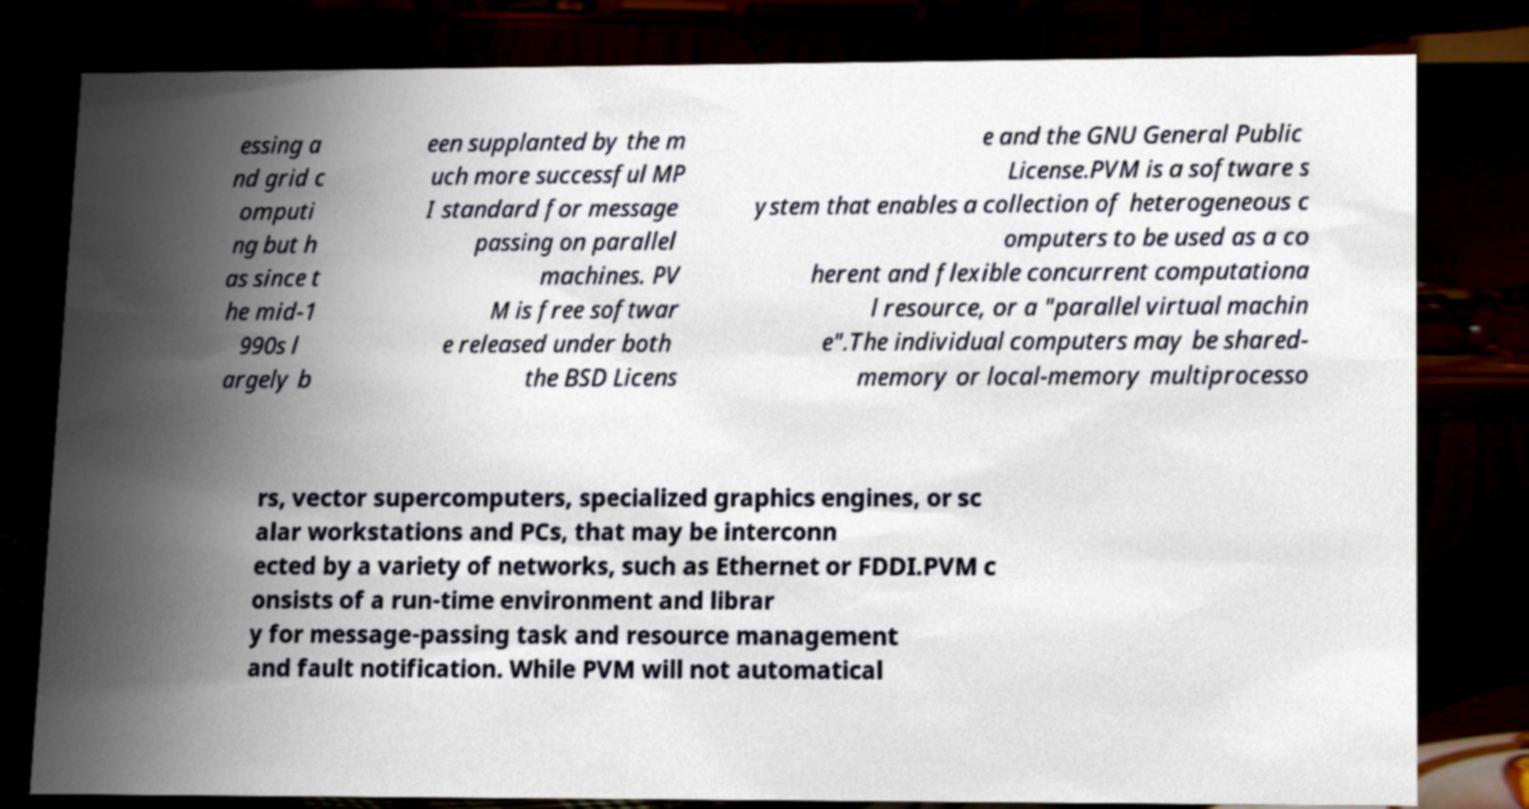For documentation purposes, I need the text within this image transcribed. Could you provide that? essing a nd grid c omputi ng but h as since t he mid-1 990s l argely b een supplanted by the m uch more successful MP I standard for message passing on parallel machines. PV M is free softwar e released under both the BSD Licens e and the GNU General Public License.PVM is a software s ystem that enables a collection of heterogeneous c omputers to be used as a co herent and flexible concurrent computationa l resource, or a "parallel virtual machin e".The individual computers may be shared- memory or local-memory multiprocesso rs, vector supercomputers, specialized graphics engines, or sc alar workstations and PCs, that may be interconn ected by a variety of networks, such as Ethernet or FDDI.PVM c onsists of a run-time environment and librar y for message-passing task and resource management and fault notification. While PVM will not automatical 